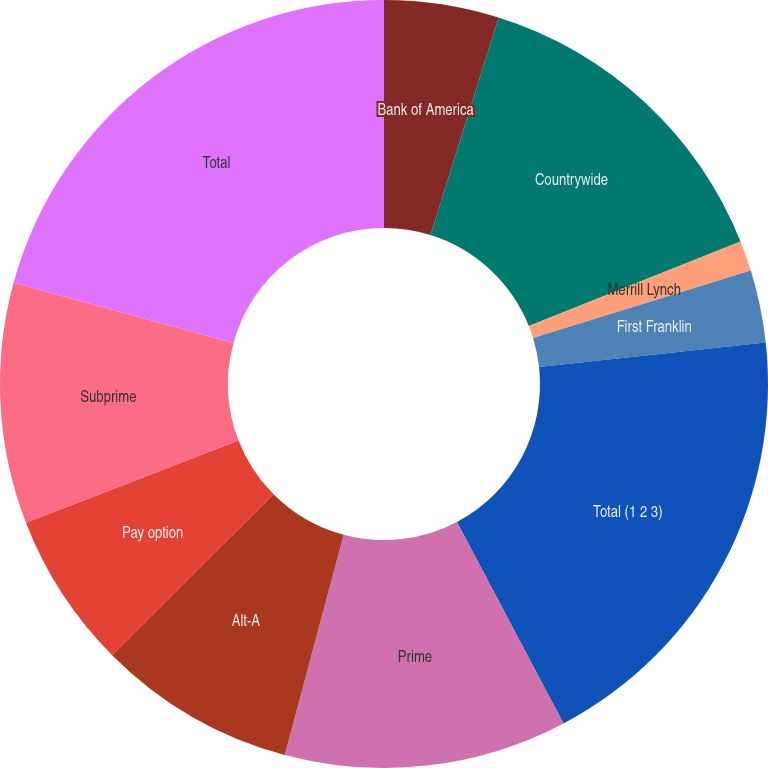Convert chart. <chart><loc_0><loc_0><loc_500><loc_500><pie_chart><fcel>Bank of America<fcel>Countrywide<fcel>Merrill Lynch<fcel>First Franklin<fcel>Total (1 2 3)<fcel>Prime<fcel>Alt-A<fcel>Pay option<fcel>Subprime<fcel>Total<nl><fcel>4.82%<fcel>14.12%<fcel>1.28%<fcel>3.05%<fcel>18.98%<fcel>11.9%<fcel>8.36%<fcel>6.59%<fcel>10.13%<fcel>20.75%<nl></chart> 